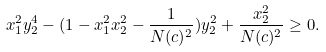<formula> <loc_0><loc_0><loc_500><loc_500>x _ { 1 } ^ { 2 } y _ { 2 } ^ { 4 } - ( 1 - x _ { 1 } ^ { 2 } x _ { 2 } ^ { 2 } - \frac { 1 } { N ( c ) ^ { 2 } } ) y _ { 2 } ^ { 2 } + \frac { x _ { 2 } ^ { 2 } } { N ( c ) ^ { 2 } } \geq 0 .</formula> 